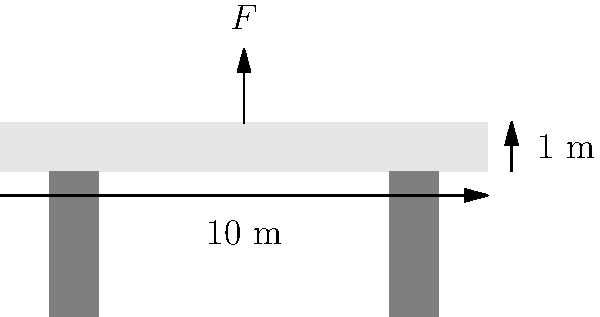A raised platform for a religious ceremony is 10 meters long, 1 meter high, and supported by two columns, each 1 meter wide, placed 1 meter from each end. If the platform is designed to support a uniformly distributed load of 5 kN/m², what is the maximum number of people (average weight 75 kg) that can safely stand on the platform, assuming a safety factor of 1.5? Let's approach this step-by-step:

1) First, calculate the area of the platform:
   Area = Length × Width
   We know the length is 10 m, but the width is not given. Let's assume it's 5 m wide.
   Area = 10 m × 5 m = 50 m²

2) Calculate the total load capacity:
   Load capacity = Area × Distributed load
   Load capacity = 50 m² × 5 kN/m² = 250 kN

3) Convert the load capacity to kg:
   250 kN = 250,000 N
   Mass = Force / Acceleration due to gravity
   Mass = 250,000 N / 9.81 m/s² ≈ 25,484 kg

4) Apply the safety factor:
   Safe load = Total load capacity / Safety factor
   Safe load = 25,484 kg / 1.5 ≈ 16,989 kg

5) Calculate the number of people:
   Number of people = Safe load / Average weight per person
   Number of people = 16,989 kg / 75 kg ≈ 226 people

Therefore, the platform can safely support approximately 226 people.
Answer: 226 people 